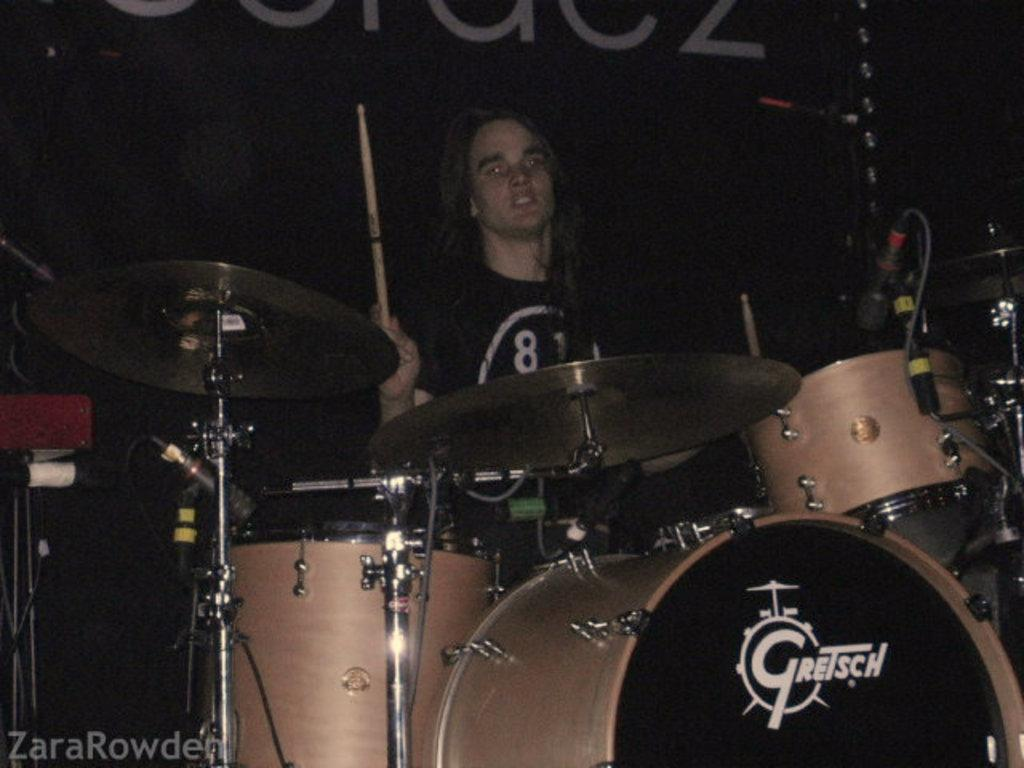What is the man in the image doing? The man is sitting on a chair in the image. What instrument is associated with the man in the image? The man is holding drumsticks, which suggests he is playing or about to play a drum set. Can you describe the drum set in the image? There is a drum set in the image. What else is visible in the image besides the man and the drum set? There is a banner visible in the image. What type of prose can be seen on the banner in the image? There is no prose visible on the banner in the image. How does the man use the brake while sitting on the chair? The man is not using a brake in the image; he is holding drumsticks and sitting on a chair. 